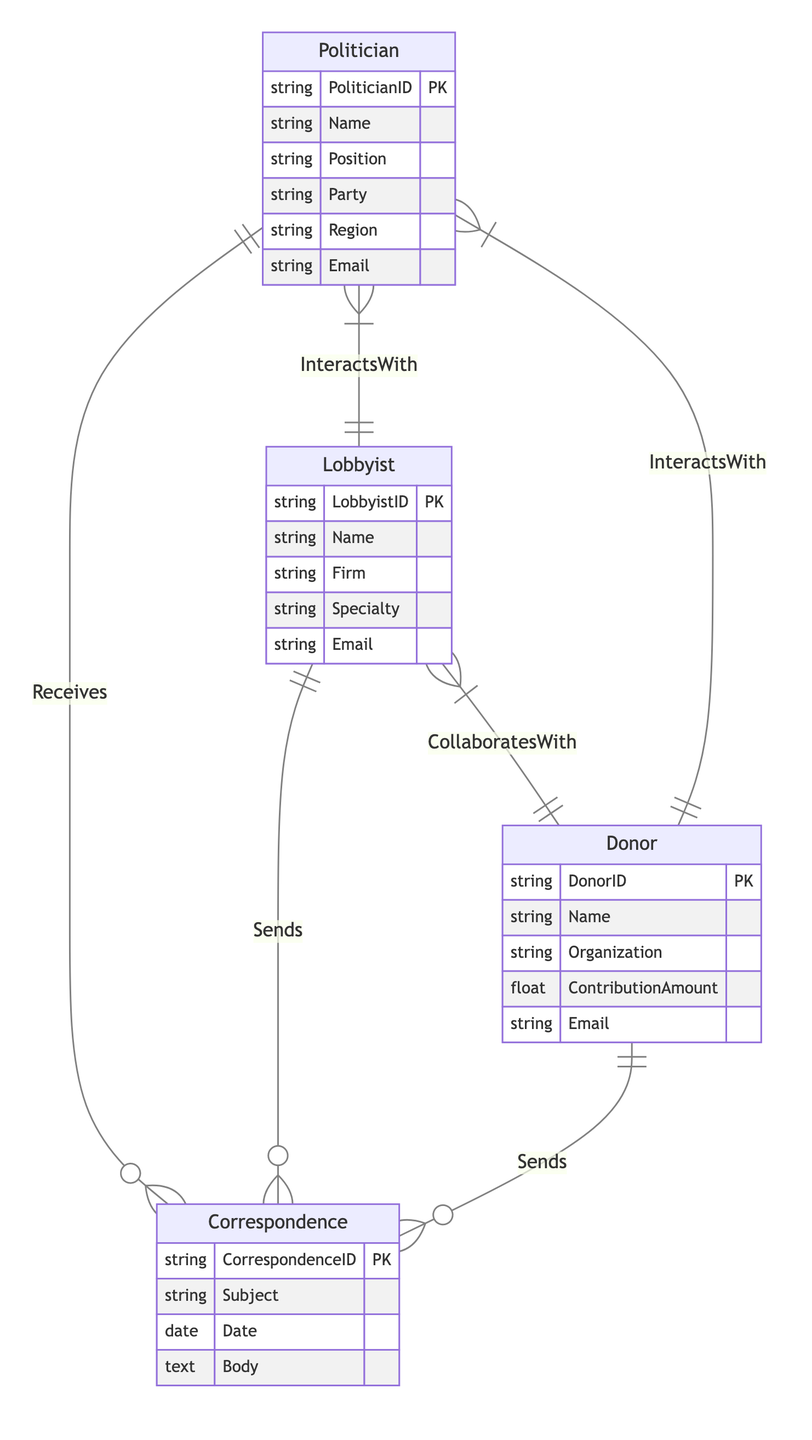What is the primary relationship type between Politicians and Correspondence? The diagram shows a "OneToMany" relationship between Politician and Correspondence, indicating that one Politician can receive multiple instances of Correspondence.
Answer: OneToMany How many entities are present in the diagram? The diagram has four entities: Politician, Lobbyist, Donor, and Correspondence.
Answer: Four What relationship links Donors and Lobbyists? The diagram clearly indicates a "ManyToMany" relationship between Lobbyists and Donors through the correspondence that they send.
Answer: CollaboratesWith How many different types of correspondence can a Politician receive? Since the diagram specifies a "OneToMany" relationship, multiple Correspondence instances can be related to a single Politician. There's no numerical limit provided, indicating many possible correspondences.
Answer: Many Which entity sends Correspondence to Politicians? The diagram indicates that both Lobbyists and Donors send Correspondence, as evidenced by their "OneToMany" relationship with Correspondence.
Answer: Lobbyists and Donors What is the email attribute associated with Donors? In the Donor entity shown in the diagram, the email attribute is explicitly listed as "Email," which means each Donor has one associated email address.
Answer: Email What is the relationship between Politicians and Lobbyists? The diagram illustrates that the relationship between Politicians and Lobbyists is "ManyToMany," meaning multiple Politicians can interact with multiple Lobbyists through Correspondence.
Answer: InteractsWith Which attribute helps identify a unique Politician? The Politician entity contains the attribute "PoliticianID," which serves as the primary key to uniquely identify each Politician in the diagram.
Answer: PoliticianID 